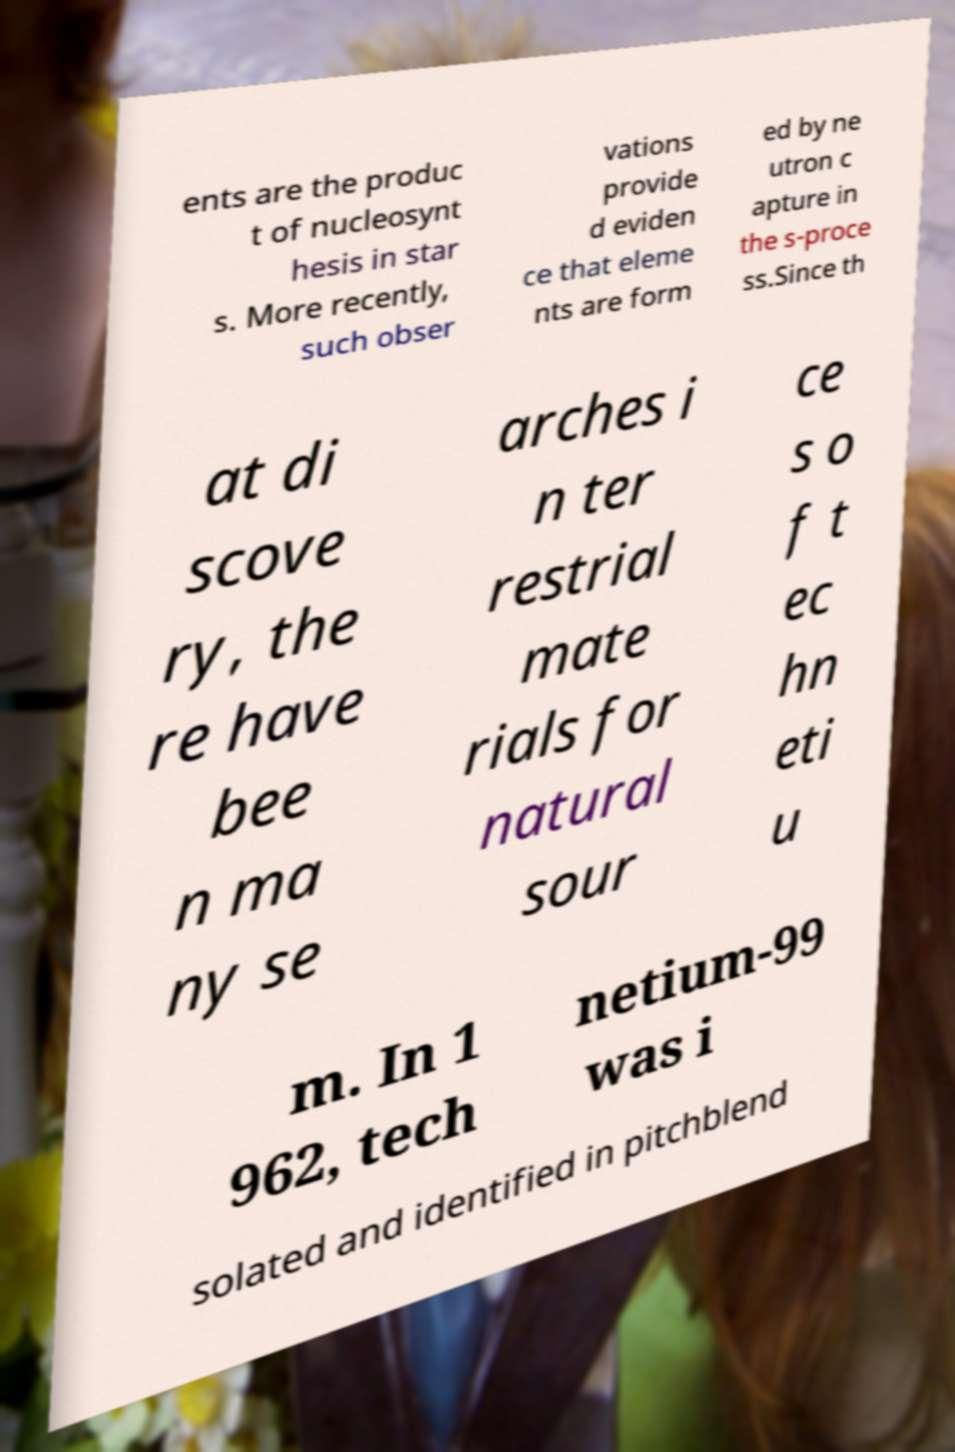What messages or text are displayed in this image? I need them in a readable, typed format. ents are the produc t of nucleosynt hesis in star s. More recently, such obser vations provide d eviden ce that eleme nts are form ed by ne utron c apture in the s-proce ss.Since th at di scove ry, the re have bee n ma ny se arches i n ter restrial mate rials for natural sour ce s o f t ec hn eti u m. In 1 962, tech netium-99 was i solated and identified in pitchblend 